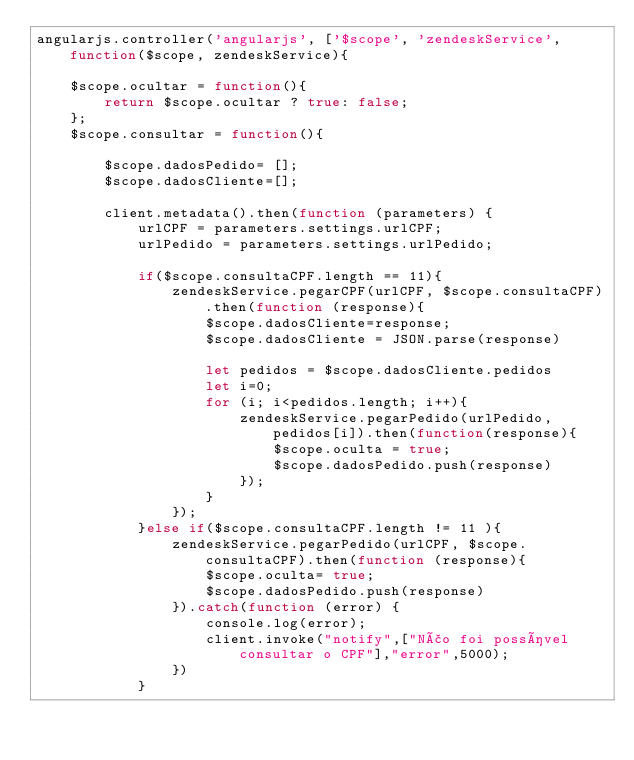Convert code to text. <code><loc_0><loc_0><loc_500><loc_500><_JavaScript_>angularjs.controller('angularjs', ['$scope', 'zendeskService', function($scope, zendeskService){
     
    $scope.ocultar = function(){
        return $scope.ocultar ? true: false;
    };  
    $scope.consultar = function(){
        
        $scope.dadosPedido= [];
        $scope.dadosCliente=[];

        client.metadata().then(function (parameters) {
            urlCPF = parameters.settings.urlCPF;
            urlPedido = parameters.settings.urlPedido;
            
            if($scope.consultaCPF.length == 11){
                zendeskService.pegarCPF(urlCPF, $scope.consultaCPF).then(function (response){
                    $scope.dadosCliente=response;
                    $scope.dadosCliente = JSON.parse(response)
                    
                    let pedidos = $scope.dadosCliente.pedidos
                    let i=0;              
                    for (i; i<pedidos.length; i++){
                        zendeskService.pegarPedido(urlPedido, pedidos[i]).then(function(response){
                            $scope.oculta = true;
                            $scope.dadosPedido.push(response)
                        });
                    }                     
                });
            }else if($scope.consultaCPF.length != 11 ){
                zendeskService.pegarPedido(urlCPF, $scope.consultaCPF).then(function (response){
                    $scope.oculta= true;
                    $scope.dadosPedido.push(response)               
                }).catch(function (error) {
                    console.log(error);
                    client.invoke("notify",["Não foi possível consultar o CPF"],"error",5000);
                })
            }</code> 